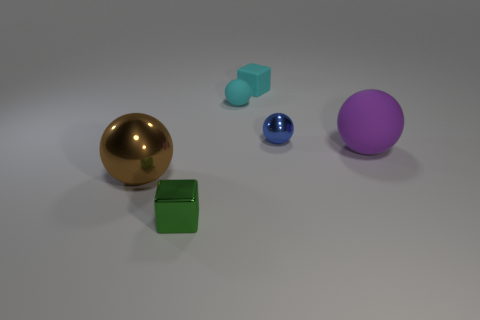Subtract all cyan matte spheres. How many spheres are left? 3 Add 1 large metal spheres. How many objects exist? 7 Subtract all purple spheres. How many spheres are left? 3 Subtract all spheres. How many objects are left? 2 Subtract 3 balls. How many balls are left? 1 Subtract all purple blocks. Subtract all cyan cylinders. How many blocks are left? 2 Subtract all yellow cylinders. How many cyan blocks are left? 1 Subtract all green cubes. Subtract all tiny rubber cubes. How many objects are left? 4 Add 6 green things. How many green things are left? 7 Add 5 tiny metallic balls. How many tiny metallic balls exist? 6 